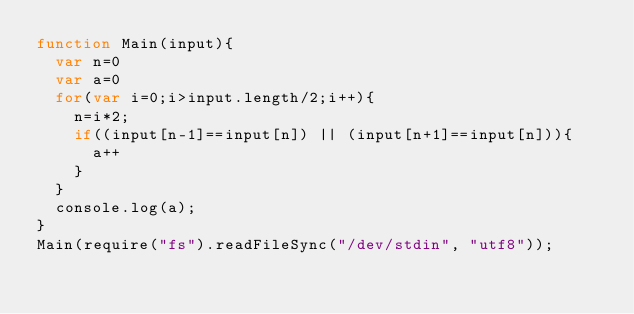Convert code to text. <code><loc_0><loc_0><loc_500><loc_500><_JavaScript_>function Main(input){
  var n=0
  var a=0
  for(var i=0;i>input.length/2;i++){
    n=i*2;
    if((input[n-1]==input[n]) || (input[n+1]==input[n])){
      a++
    }
  }
  console.log(a);
}
Main(require("fs").readFileSync("/dev/stdin", "utf8"));</code> 